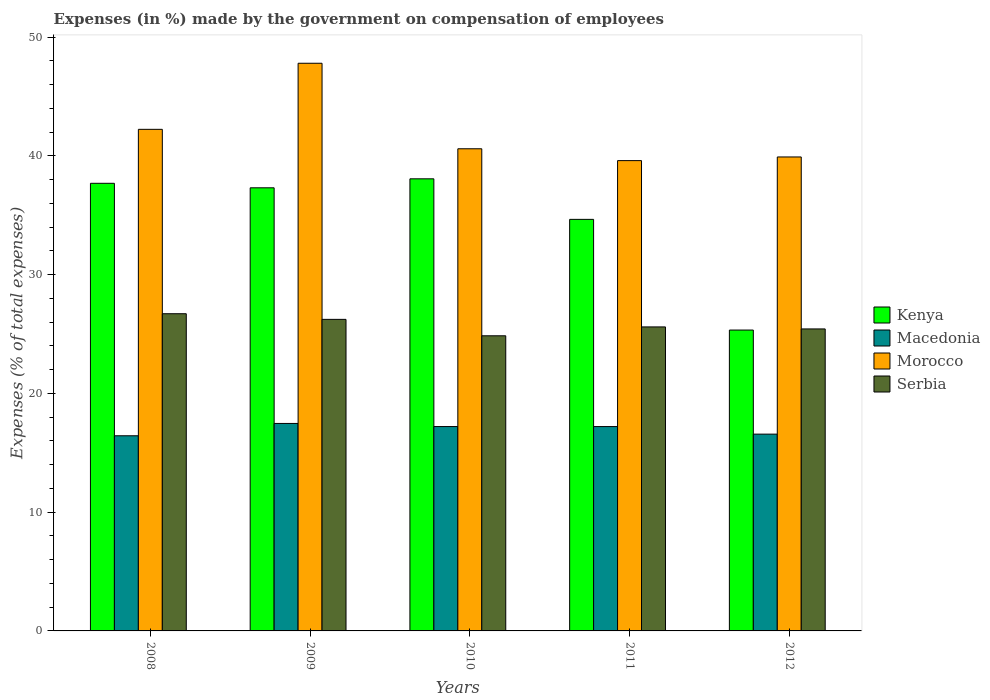How many different coloured bars are there?
Your answer should be compact. 4. Are the number of bars on each tick of the X-axis equal?
Your answer should be very brief. Yes. How many bars are there on the 3rd tick from the left?
Ensure brevity in your answer.  4. What is the label of the 2nd group of bars from the left?
Offer a terse response. 2009. In how many cases, is the number of bars for a given year not equal to the number of legend labels?
Keep it short and to the point. 0. What is the percentage of expenses made by the government on compensation of employees in Macedonia in 2009?
Your answer should be compact. 17.47. Across all years, what is the maximum percentage of expenses made by the government on compensation of employees in Serbia?
Your response must be concise. 26.71. Across all years, what is the minimum percentage of expenses made by the government on compensation of employees in Serbia?
Offer a terse response. 24.85. In which year was the percentage of expenses made by the government on compensation of employees in Morocco minimum?
Your response must be concise. 2011. What is the total percentage of expenses made by the government on compensation of employees in Morocco in the graph?
Provide a succinct answer. 210.13. What is the difference between the percentage of expenses made by the government on compensation of employees in Macedonia in 2008 and that in 2012?
Your response must be concise. -0.14. What is the difference between the percentage of expenses made by the government on compensation of employees in Macedonia in 2010 and the percentage of expenses made by the government on compensation of employees in Kenya in 2009?
Your response must be concise. -20.1. What is the average percentage of expenses made by the government on compensation of employees in Kenya per year?
Your answer should be very brief. 34.61. In the year 2009, what is the difference between the percentage of expenses made by the government on compensation of employees in Kenya and percentage of expenses made by the government on compensation of employees in Morocco?
Your answer should be compact. -10.49. What is the ratio of the percentage of expenses made by the government on compensation of employees in Kenya in 2009 to that in 2012?
Ensure brevity in your answer.  1.47. What is the difference between the highest and the second highest percentage of expenses made by the government on compensation of employees in Kenya?
Make the answer very short. 0.38. What is the difference between the highest and the lowest percentage of expenses made by the government on compensation of employees in Macedonia?
Keep it short and to the point. 1.04. Is it the case that in every year, the sum of the percentage of expenses made by the government on compensation of employees in Morocco and percentage of expenses made by the government on compensation of employees in Macedonia is greater than the sum of percentage of expenses made by the government on compensation of employees in Kenya and percentage of expenses made by the government on compensation of employees in Serbia?
Your answer should be compact. No. What does the 1st bar from the left in 2012 represents?
Provide a short and direct response. Kenya. What does the 4th bar from the right in 2012 represents?
Your response must be concise. Kenya. Is it the case that in every year, the sum of the percentage of expenses made by the government on compensation of employees in Kenya and percentage of expenses made by the government on compensation of employees in Serbia is greater than the percentage of expenses made by the government on compensation of employees in Morocco?
Ensure brevity in your answer.  Yes. Are all the bars in the graph horizontal?
Make the answer very short. No. How many years are there in the graph?
Keep it short and to the point. 5. What is the difference between two consecutive major ticks on the Y-axis?
Provide a succinct answer. 10. Are the values on the major ticks of Y-axis written in scientific E-notation?
Give a very brief answer. No. Does the graph contain any zero values?
Offer a very short reply. No. Does the graph contain grids?
Your response must be concise. No. How are the legend labels stacked?
Keep it short and to the point. Vertical. What is the title of the graph?
Your answer should be very brief. Expenses (in %) made by the government on compensation of employees. Does "India" appear as one of the legend labels in the graph?
Offer a very short reply. No. What is the label or title of the X-axis?
Your answer should be very brief. Years. What is the label or title of the Y-axis?
Make the answer very short. Expenses (% of total expenses). What is the Expenses (% of total expenses) of Kenya in 2008?
Offer a terse response. 37.69. What is the Expenses (% of total expenses) in Macedonia in 2008?
Provide a succinct answer. 16.43. What is the Expenses (% of total expenses) in Morocco in 2008?
Offer a very short reply. 42.23. What is the Expenses (% of total expenses) in Serbia in 2008?
Provide a succinct answer. 26.71. What is the Expenses (% of total expenses) of Kenya in 2009?
Make the answer very short. 37.31. What is the Expenses (% of total expenses) of Macedonia in 2009?
Provide a short and direct response. 17.47. What is the Expenses (% of total expenses) in Morocco in 2009?
Provide a short and direct response. 47.8. What is the Expenses (% of total expenses) of Serbia in 2009?
Provide a short and direct response. 26.23. What is the Expenses (% of total expenses) of Kenya in 2010?
Make the answer very short. 38.07. What is the Expenses (% of total expenses) in Macedonia in 2010?
Offer a very short reply. 17.21. What is the Expenses (% of total expenses) of Morocco in 2010?
Give a very brief answer. 40.6. What is the Expenses (% of total expenses) in Serbia in 2010?
Your answer should be very brief. 24.85. What is the Expenses (% of total expenses) of Kenya in 2011?
Keep it short and to the point. 34.65. What is the Expenses (% of total expenses) in Macedonia in 2011?
Your response must be concise. 17.21. What is the Expenses (% of total expenses) in Morocco in 2011?
Provide a short and direct response. 39.6. What is the Expenses (% of total expenses) of Serbia in 2011?
Give a very brief answer. 25.6. What is the Expenses (% of total expenses) in Kenya in 2012?
Provide a succinct answer. 25.33. What is the Expenses (% of total expenses) of Macedonia in 2012?
Ensure brevity in your answer.  16.57. What is the Expenses (% of total expenses) in Morocco in 2012?
Provide a short and direct response. 39.91. What is the Expenses (% of total expenses) of Serbia in 2012?
Keep it short and to the point. 25.43. Across all years, what is the maximum Expenses (% of total expenses) of Kenya?
Keep it short and to the point. 38.07. Across all years, what is the maximum Expenses (% of total expenses) in Macedonia?
Offer a very short reply. 17.47. Across all years, what is the maximum Expenses (% of total expenses) of Morocco?
Your response must be concise. 47.8. Across all years, what is the maximum Expenses (% of total expenses) of Serbia?
Offer a terse response. 26.71. Across all years, what is the minimum Expenses (% of total expenses) in Kenya?
Your response must be concise. 25.33. Across all years, what is the minimum Expenses (% of total expenses) of Macedonia?
Ensure brevity in your answer.  16.43. Across all years, what is the minimum Expenses (% of total expenses) of Morocco?
Your response must be concise. 39.6. Across all years, what is the minimum Expenses (% of total expenses) in Serbia?
Provide a succinct answer. 24.85. What is the total Expenses (% of total expenses) in Kenya in the graph?
Ensure brevity in your answer.  173.05. What is the total Expenses (% of total expenses) in Macedonia in the graph?
Your response must be concise. 84.88. What is the total Expenses (% of total expenses) of Morocco in the graph?
Give a very brief answer. 210.13. What is the total Expenses (% of total expenses) of Serbia in the graph?
Your response must be concise. 128.81. What is the difference between the Expenses (% of total expenses) in Kenya in 2008 and that in 2009?
Keep it short and to the point. 0.38. What is the difference between the Expenses (% of total expenses) of Macedonia in 2008 and that in 2009?
Your answer should be very brief. -1.04. What is the difference between the Expenses (% of total expenses) of Morocco in 2008 and that in 2009?
Keep it short and to the point. -5.56. What is the difference between the Expenses (% of total expenses) in Serbia in 2008 and that in 2009?
Offer a terse response. 0.48. What is the difference between the Expenses (% of total expenses) in Kenya in 2008 and that in 2010?
Provide a succinct answer. -0.38. What is the difference between the Expenses (% of total expenses) of Macedonia in 2008 and that in 2010?
Keep it short and to the point. -0.78. What is the difference between the Expenses (% of total expenses) of Morocco in 2008 and that in 2010?
Offer a terse response. 1.64. What is the difference between the Expenses (% of total expenses) in Serbia in 2008 and that in 2010?
Ensure brevity in your answer.  1.86. What is the difference between the Expenses (% of total expenses) of Kenya in 2008 and that in 2011?
Provide a succinct answer. 3.04. What is the difference between the Expenses (% of total expenses) in Macedonia in 2008 and that in 2011?
Make the answer very short. -0.77. What is the difference between the Expenses (% of total expenses) in Morocco in 2008 and that in 2011?
Your answer should be very brief. 2.63. What is the difference between the Expenses (% of total expenses) in Kenya in 2008 and that in 2012?
Provide a succinct answer. 12.36. What is the difference between the Expenses (% of total expenses) in Macedonia in 2008 and that in 2012?
Offer a very short reply. -0.14. What is the difference between the Expenses (% of total expenses) of Morocco in 2008 and that in 2012?
Offer a terse response. 2.33. What is the difference between the Expenses (% of total expenses) in Serbia in 2008 and that in 2012?
Offer a very short reply. 1.28. What is the difference between the Expenses (% of total expenses) in Kenya in 2009 and that in 2010?
Provide a succinct answer. -0.76. What is the difference between the Expenses (% of total expenses) of Macedonia in 2009 and that in 2010?
Offer a terse response. 0.26. What is the difference between the Expenses (% of total expenses) of Morocco in 2009 and that in 2010?
Ensure brevity in your answer.  7.2. What is the difference between the Expenses (% of total expenses) in Serbia in 2009 and that in 2010?
Your response must be concise. 1.38. What is the difference between the Expenses (% of total expenses) of Kenya in 2009 and that in 2011?
Offer a terse response. 2.66. What is the difference between the Expenses (% of total expenses) in Macedonia in 2009 and that in 2011?
Your answer should be very brief. 0.26. What is the difference between the Expenses (% of total expenses) in Morocco in 2009 and that in 2011?
Ensure brevity in your answer.  8.2. What is the difference between the Expenses (% of total expenses) of Serbia in 2009 and that in 2011?
Your response must be concise. 0.64. What is the difference between the Expenses (% of total expenses) in Kenya in 2009 and that in 2012?
Provide a succinct answer. 11.98. What is the difference between the Expenses (% of total expenses) in Macedonia in 2009 and that in 2012?
Make the answer very short. 0.9. What is the difference between the Expenses (% of total expenses) in Morocco in 2009 and that in 2012?
Offer a very short reply. 7.89. What is the difference between the Expenses (% of total expenses) in Serbia in 2009 and that in 2012?
Your answer should be very brief. 0.81. What is the difference between the Expenses (% of total expenses) of Kenya in 2010 and that in 2011?
Ensure brevity in your answer.  3.41. What is the difference between the Expenses (% of total expenses) of Macedonia in 2010 and that in 2011?
Offer a terse response. 0. What is the difference between the Expenses (% of total expenses) of Morocco in 2010 and that in 2011?
Your response must be concise. 1. What is the difference between the Expenses (% of total expenses) in Serbia in 2010 and that in 2011?
Your answer should be compact. -0.75. What is the difference between the Expenses (% of total expenses) in Kenya in 2010 and that in 2012?
Offer a terse response. 12.73. What is the difference between the Expenses (% of total expenses) in Macedonia in 2010 and that in 2012?
Make the answer very short. 0.64. What is the difference between the Expenses (% of total expenses) of Morocco in 2010 and that in 2012?
Keep it short and to the point. 0.69. What is the difference between the Expenses (% of total expenses) of Serbia in 2010 and that in 2012?
Ensure brevity in your answer.  -0.58. What is the difference between the Expenses (% of total expenses) in Kenya in 2011 and that in 2012?
Provide a short and direct response. 9.32. What is the difference between the Expenses (% of total expenses) in Macedonia in 2011 and that in 2012?
Make the answer very short. 0.64. What is the difference between the Expenses (% of total expenses) of Morocco in 2011 and that in 2012?
Your answer should be very brief. -0.31. What is the difference between the Expenses (% of total expenses) of Serbia in 2011 and that in 2012?
Give a very brief answer. 0.17. What is the difference between the Expenses (% of total expenses) of Kenya in 2008 and the Expenses (% of total expenses) of Macedonia in 2009?
Keep it short and to the point. 20.22. What is the difference between the Expenses (% of total expenses) of Kenya in 2008 and the Expenses (% of total expenses) of Morocco in 2009?
Your answer should be compact. -10.11. What is the difference between the Expenses (% of total expenses) in Kenya in 2008 and the Expenses (% of total expenses) in Serbia in 2009?
Provide a succinct answer. 11.46. What is the difference between the Expenses (% of total expenses) of Macedonia in 2008 and the Expenses (% of total expenses) of Morocco in 2009?
Your response must be concise. -31.37. What is the difference between the Expenses (% of total expenses) of Macedonia in 2008 and the Expenses (% of total expenses) of Serbia in 2009?
Offer a very short reply. -9.8. What is the difference between the Expenses (% of total expenses) of Morocco in 2008 and the Expenses (% of total expenses) of Serbia in 2009?
Make the answer very short. 16. What is the difference between the Expenses (% of total expenses) of Kenya in 2008 and the Expenses (% of total expenses) of Macedonia in 2010?
Provide a succinct answer. 20.48. What is the difference between the Expenses (% of total expenses) in Kenya in 2008 and the Expenses (% of total expenses) in Morocco in 2010?
Provide a short and direct response. -2.91. What is the difference between the Expenses (% of total expenses) of Kenya in 2008 and the Expenses (% of total expenses) of Serbia in 2010?
Your response must be concise. 12.84. What is the difference between the Expenses (% of total expenses) of Macedonia in 2008 and the Expenses (% of total expenses) of Morocco in 2010?
Keep it short and to the point. -24.16. What is the difference between the Expenses (% of total expenses) in Macedonia in 2008 and the Expenses (% of total expenses) in Serbia in 2010?
Provide a succinct answer. -8.42. What is the difference between the Expenses (% of total expenses) in Morocco in 2008 and the Expenses (% of total expenses) in Serbia in 2010?
Your response must be concise. 17.38. What is the difference between the Expenses (% of total expenses) in Kenya in 2008 and the Expenses (% of total expenses) in Macedonia in 2011?
Make the answer very short. 20.48. What is the difference between the Expenses (% of total expenses) in Kenya in 2008 and the Expenses (% of total expenses) in Morocco in 2011?
Your answer should be very brief. -1.91. What is the difference between the Expenses (% of total expenses) in Kenya in 2008 and the Expenses (% of total expenses) in Serbia in 2011?
Provide a succinct answer. 12.09. What is the difference between the Expenses (% of total expenses) of Macedonia in 2008 and the Expenses (% of total expenses) of Morocco in 2011?
Offer a terse response. -23.17. What is the difference between the Expenses (% of total expenses) in Macedonia in 2008 and the Expenses (% of total expenses) in Serbia in 2011?
Provide a succinct answer. -9.17. What is the difference between the Expenses (% of total expenses) of Morocco in 2008 and the Expenses (% of total expenses) of Serbia in 2011?
Your answer should be very brief. 16.64. What is the difference between the Expenses (% of total expenses) of Kenya in 2008 and the Expenses (% of total expenses) of Macedonia in 2012?
Your response must be concise. 21.12. What is the difference between the Expenses (% of total expenses) of Kenya in 2008 and the Expenses (% of total expenses) of Morocco in 2012?
Keep it short and to the point. -2.22. What is the difference between the Expenses (% of total expenses) of Kenya in 2008 and the Expenses (% of total expenses) of Serbia in 2012?
Make the answer very short. 12.26. What is the difference between the Expenses (% of total expenses) of Macedonia in 2008 and the Expenses (% of total expenses) of Morocco in 2012?
Make the answer very short. -23.48. What is the difference between the Expenses (% of total expenses) in Macedonia in 2008 and the Expenses (% of total expenses) in Serbia in 2012?
Your answer should be very brief. -9. What is the difference between the Expenses (% of total expenses) in Morocco in 2008 and the Expenses (% of total expenses) in Serbia in 2012?
Keep it short and to the point. 16.81. What is the difference between the Expenses (% of total expenses) in Kenya in 2009 and the Expenses (% of total expenses) in Macedonia in 2010?
Keep it short and to the point. 20.1. What is the difference between the Expenses (% of total expenses) of Kenya in 2009 and the Expenses (% of total expenses) of Morocco in 2010?
Offer a very short reply. -3.29. What is the difference between the Expenses (% of total expenses) in Kenya in 2009 and the Expenses (% of total expenses) in Serbia in 2010?
Offer a very short reply. 12.46. What is the difference between the Expenses (% of total expenses) in Macedonia in 2009 and the Expenses (% of total expenses) in Morocco in 2010?
Offer a terse response. -23.13. What is the difference between the Expenses (% of total expenses) in Macedonia in 2009 and the Expenses (% of total expenses) in Serbia in 2010?
Offer a very short reply. -7.38. What is the difference between the Expenses (% of total expenses) in Morocco in 2009 and the Expenses (% of total expenses) in Serbia in 2010?
Offer a terse response. 22.95. What is the difference between the Expenses (% of total expenses) of Kenya in 2009 and the Expenses (% of total expenses) of Macedonia in 2011?
Your answer should be very brief. 20.1. What is the difference between the Expenses (% of total expenses) in Kenya in 2009 and the Expenses (% of total expenses) in Morocco in 2011?
Provide a succinct answer. -2.29. What is the difference between the Expenses (% of total expenses) in Kenya in 2009 and the Expenses (% of total expenses) in Serbia in 2011?
Provide a short and direct response. 11.71. What is the difference between the Expenses (% of total expenses) in Macedonia in 2009 and the Expenses (% of total expenses) in Morocco in 2011?
Offer a very short reply. -22.13. What is the difference between the Expenses (% of total expenses) in Macedonia in 2009 and the Expenses (% of total expenses) in Serbia in 2011?
Your answer should be compact. -8.13. What is the difference between the Expenses (% of total expenses) in Morocco in 2009 and the Expenses (% of total expenses) in Serbia in 2011?
Offer a terse response. 22.2. What is the difference between the Expenses (% of total expenses) in Kenya in 2009 and the Expenses (% of total expenses) in Macedonia in 2012?
Your answer should be compact. 20.74. What is the difference between the Expenses (% of total expenses) in Kenya in 2009 and the Expenses (% of total expenses) in Morocco in 2012?
Make the answer very short. -2.6. What is the difference between the Expenses (% of total expenses) of Kenya in 2009 and the Expenses (% of total expenses) of Serbia in 2012?
Your answer should be very brief. 11.88. What is the difference between the Expenses (% of total expenses) of Macedonia in 2009 and the Expenses (% of total expenses) of Morocco in 2012?
Give a very brief answer. -22.44. What is the difference between the Expenses (% of total expenses) of Macedonia in 2009 and the Expenses (% of total expenses) of Serbia in 2012?
Keep it short and to the point. -7.96. What is the difference between the Expenses (% of total expenses) of Morocco in 2009 and the Expenses (% of total expenses) of Serbia in 2012?
Give a very brief answer. 22.37. What is the difference between the Expenses (% of total expenses) in Kenya in 2010 and the Expenses (% of total expenses) in Macedonia in 2011?
Your response must be concise. 20.86. What is the difference between the Expenses (% of total expenses) of Kenya in 2010 and the Expenses (% of total expenses) of Morocco in 2011?
Offer a very short reply. -1.53. What is the difference between the Expenses (% of total expenses) of Kenya in 2010 and the Expenses (% of total expenses) of Serbia in 2011?
Provide a succinct answer. 12.47. What is the difference between the Expenses (% of total expenses) of Macedonia in 2010 and the Expenses (% of total expenses) of Morocco in 2011?
Your response must be concise. -22.39. What is the difference between the Expenses (% of total expenses) of Macedonia in 2010 and the Expenses (% of total expenses) of Serbia in 2011?
Your answer should be very brief. -8.39. What is the difference between the Expenses (% of total expenses) of Morocco in 2010 and the Expenses (% of total expenses) of Serbia in 2011?
Your answer should be very brief. 15. What is the difference between the Expenses (% of total expenses) of Kenya in 2010 and the Expenses (% of total expenses) of Macedonia in 2012?
Give a very brief answer. 21.5. What is the difference between the Expenses (% of total expenses) of Kenya in 2010 and the Expenses (% of total expenses) of Morocco in 2012?
Provide a short and direct response. -1.84. What is the difference between the Expenses (% of total expenses) in Kenya in 2010 and the Expenses (% of total expenses) in Serbia in 2012?
Ensure brevity in your answer.  12.64. What is the difference between the Expenses (% of total expenses) in Macedonia in 2010 and the Expenses (% of total expenses) in Morocco in 2012?
Offer a very short reply. -22.7. What is the difference between the Expenses (% of total expenses) in Macedonia in 2010 and the Expenses (% of total expenses) in Serbia in 2012?
Provide a succinct answer. -8.22. What is the difference between the Expenses (% of total expenses) in Morocco in 2010 and the Expenses (% of total expenses) in Serbia in 2012?
Give a very brief answer. 15.17. What is the difference between the Expenses (% of total expenses) in Kenya in 2011 and the Expenses (% of total expenses) in Macedonia in 2012?
Ensure brevity in your answer.  18.08. What is the difference between the Expenses (% of total expenses) in Kenya in 2011 and the Expenses (% of total expenses) in Morocco in 2012?
Keep it short and to the point. -5.25. What is the difference between the Expenses (% of total expenses) in Kenya in 2011 and the Expenses (% of total expenses) in Serbia in 2012?
Your answer should be compact. 9.23. What is the difference between the Expenses (% of total expenses) in Macedonia in 2011 and the Expenses (% of total expenses) in Morocco in 2012?
Provide a short and direct response. -22.7. What is the difference between the Expenses (% of total expenses) in Macedonia in 2011 and the Expenses (% of total expenses) in Serbia in 2012?
Your answer should be very brief. -8.22. What is the difference between the Expenses (% of total expenses) of Morocco in 2011 and the Expenses (% of total expenses) of Serbia in 2012?
Your answer should be compact. 14.17. What is the average Expenses (% of total expenses) of Kenya per year?
Your answer should be very brief. 34.61. What is the average Expenses (% of total expenses) in Macedonia per year?
Make the answer very short. 16.98. What is the average Expenses (% of total expenses) in Morocco per year?
Your answer should be compact. 42.03. What is the average Expenses (% of total expenses) in Serbia per year?
Offer a very short reply. 25.76. In the year 2008, what is the difference between the Expenses (% of total expenses) in Kenya and Expenses (% of total expenses) in Macedonia?
Your answer should be compact. 21.26. In the year 2008, what is the difference between the Expenses (% of total expenses) in Kenya and Expenses (% of total expenses) in Morocco?
Provide a short and direct response. -4.54. In the year 2008, what is the difference between the Expenses (% of total expenses) in Kenya and Expenses (% of total expenses) in Serbia?
Offer a terse response. 10.98. In the year 2008, what is the difference between the Expenses (% of total expenses) of Macedonia and Expenses (% of total expenses) of Morocco?
Provide a short and direct response. -25.8. In the year 2008, what is the difference between the Expenses (% of total expenses) in Macedonia and Expenses (% of total expenses) in Serbia?
Provide a succinct answer. -10.28. In the year 2008, what is the difference between the Expenses (% of total expenses) in Morocco and Expenses (% of total expenses) in Serbia?
Ensure brevity in your answer.  15.53. In the year 2009, what is the difference between the Expenses (% of total expenses) in Kenya and Expenses (% of total expenses) in Macedonia?
Offer a very short reply. 19.84. In the year 2009, what is the difference between the Expenses (% of total expenses) in Kenya and Expenses (% of total expenses) in Morocco?
Make the answer very short. -10.49. In the year 2009, what is the difference between the Expenses (% of total expenses) of Kenya and Expenses (% of total expenses) of Serbia?
Your answer should be compact. 11.08. In the year 2009, what is the difference between the Expenses (% of total expenses) of Macedonia and Expenses (% of total expenses) of Morocco?
Your answer should be very brief. -30.33. In the year 2009, what is the difference between the Expenses (% of total expenses) of Macedonia and Expenses (% of total expenses) of Serbia?
Keep it short and to the point. -8.76. In the year 2009, what is the difference between the Expenses (% of total expenses) of Morocco and Expenses (% of total expenses) of Serbia?
Provide a succinct answer. 21.56. In the year 2010, what is the difference between the Expenses (% of total expenses) in Kenya and Expenses (% of total expenses) in Macedonia?
Give a very brief answer. 20.86. In the year 2010, what is the difference between the Expenses (% of total expenses) in Kenya and Expenses (% of total expenses) in Morocco?
Offer a very short reply. -2.53. In the year 2010, what is the difference between the Expenses (% of total expenses) in Kenya and Expenses (% of total expenses) in Serbia?
Your response must be concise. 13.22. In the year 2010, what is the difference between the Expenses (% of total expenses) of Macedonia and Expenses (% of total expenses) of Morocco?
Provide a succinct answer. -23.39. In the year 2010, what is the difference between the Expenses (% of total expenses) of Macedonia and Expenses (% of total expenses) of Serbia?
Provide a succinct answer. -7.64. In the year 2010, what is the difference between the Expenses (% of total expenses) in Morocco and Expenses (% of total expenses) in Serbia?
Your response must be concise. 15.75. In the year 2011, what is the difference between the Expenses (% of total expenses) of Kenya and Expenses (% of total expenses) of Macedonia?
Provide a short and direct response. 17.45. In the year 2011, what is the difference between the Expenses (% of total expenses) in Kenya and Expenses (% of total expenses) in Morocco?
Your answer should be compact. -4.95. In the year 2011, what is the difference between the Expenses (% of total expenses) in Kenya and Expenses (% of total expenses) in Serbia?
Keep it short and to the point. 9.06. In the year 2011, what is the difference between the Expenses (% of total expenses) in Macedonia and Expenses (% of total expenses) in Morocco?
Offer a very short reply. -22.39. In the year 2011, what is the difference between the Expenses (% of total expenses) in Macedonia and Expenses (% of total expenses) in Serbia?
Provide a succinct answer. -8.39. In the year 2011, what is the difference between the Expenses (% of total expenses) in Morocco and Expenses (% of total expenses) in Serbia?
Ensure brevity in your answer.  14. In the year 2012, what is the difference between the Expenses (% of total expenses) of Kenya and Expenses (% of total expenses) of Macedonia?
Give a very brief answer. 8.76. In the year 2012, what is the difference between the Expenses (% of total expenses) of Kenya and Expenses (% of total expenses) of Morocco?
Offer a terse response. -14.57. In the year 2012, what is the difference between the Expenses (% of total expenses) of Kenya and Expenses (% of total expenses) of Serbia?
Your answer should be very brief. -0.09. In the year 2012, what is the difference between the Expenses (% of total expenses) in Macedonia and Expenses (% of total expenses) in Morocco?
Give a very brief answer. -23.34. In the year 2012, what is the difference between the Expenses (% of total expenses) of Macedonia and Expenses (% of total expenses) of Serbia?
Your answer should be compact. -8.86. In the year 2012, what is the difference between the Expenses (% of total expenses) of Morocco and Expenses (% of total expenses) of Serbia?
Offer a terse response. 14.48. What is the ratio of the Expenses (% of total expenses) in Kenya in 2008 to that in 2009?
Provide a short and direct response. 1.01. What is the ratio of the Expenses (% of total expenses) of Macedonia in 2008 to that in 2009?
Give a very brief answer. 0.94. What is the ratio of the Expenses (% of total expenses) in Morocco in 2008 to that in 2009?
Offer a very short reply. 0.88. What is the ratio of the Expenses (% of total expenses) in Serbia in 2008 to that in 2009?
Provide a short and direct response. 1.02. What is the ratio of the Expenses (% of total expenses) in Kenya in 2008 to that in 2010?
Provide a succinct answer. 0.99. What is the ratio of the Expenses (% of total expenses) of Macedonia in 2008 to that in 2010?
Your answer should be very brief. 0.95. What is the ratio of the Expenses (% of total expenses) of Morocco in 2008 to that in 2010?
Ensure brevity in your answer.  1.04. What is the ratio of the Expenses (% of total expenses) in Serbia in 2008 to that in 2010?
Make the answer very short. 1.07. What is the ratio of the Expenses (% of total expenses) in Kenya in 2008 to that in 2011?
Provide a succinct answer. 1.09. What is the ratio of the Expenses (% of total expenses) in Macedonia in 2008 to that in 2011?
Your response must be concise. 0.95. What is the ratio of the Expenses (% of total expenses) of Morocco in 2008 to that in 2011?
Keep it short and to the point. 1.07. What is the ratio of the Expenses (% of total expenses) of Serbia in 2008 to that in 2011?
Your answer should be very brief. 1.04. What is the ratio of the Expenses (% of total expenses) of Kenya in 2008 to that in 2012?
Your response must be concise. 1.49. What is the ratio of the Expenses (% of total expenses) of Macedonia in 2008 to that in 2012?
Keep it short and to the point. 0.99. What is the ratio of the Expenses (% of total expenses) of Morocco in 2008 to that in 2012?
Offer a very short reply. 1.06. What is the ratio of the Expenses (% of total expenses) of Serbia in 2008 to that in 2012?
Your answer should be compact. 1.05. What is the ratio of the Expenses (% of total expenses) of Kenya in 2009 to that in 2010?
Provide a short and direct response. 0.98. What is the ratio of the Expenses (% of total expenses) of Macedonia in 2009 to that in 2010?
Offer a very short reply. 1.02. What is the ratio of the Expenses (% of total expenses) in Morocco in 2009 to that in 2010?
Your answer should be very brief. 1.18. What is the ratio of the Expenses (% of total expenses) of Serbia in 2009 to that in 2010?
Give a very brief answer. 1.06. What is the ratio of the Expenses (% of total expenses) of Kenya in 2009 to that in 2011?
Offer a very short reply. 1.08. What is the ratio of the Expenses (% of total expenses) in Macedonia in 2009 to that in 2011?
Offer a very short reply. 1.02. What is the ratio of the Expenses (% of total expenses) in Morocco in 2009 to that in 2011?
Your response must be concise. 1.21. What is the ratio of the Expenses (% of total expenses) of Serbia in 2009 to that in 2011?
Keep it short and to the point. 1.02. What is the ratio of the Expenses (% of total expenses) in Kenya in 2009 to that in 2012?
Your response must be concise. 1.47. What is the ratio of the Expenses (% of total expenses) in Macedonia in 2009 to that in 2012?
Your answer should be very brief. 1.05. What is the ratio of the Expenses (% of total expenses) in Morocco in 2009 to that in 2012?
Offer a very short reply. 1.2. What is the ratio of the Expenses (% of total expenses) in Serbia in 2009 to that in 2012?
Your answer should be very brief. 1.03. What is the ratio of the Expenses (% of total expenses) of Kenya in 2010 to that in 2011?
Provide a short and direct response. 1.1. What is the ratio of the Expenses (% of total expenses) in Morocco in 2010 to that in 2011?
Give a very brief answer. 1.03. What is the ratio of the Expenses (% of total expenses) in Serbia in 2010 to that in 2011?
Give a very brief answer. 0.97. What is the ratio of the Expenses (% of total expenses) in Kenya in 2010 to that in 2012?
Provide a succinct answer. 1.5. What is the ratio of the Expenses (% of total expenses) of Macedonia in 2010 to that in 2012?
Your answer should be very brief. 1.04. What is the ratio of the Expenses (% of total expenses) in Morocco in 2010 to that in 2012?
Give a very brief answer. 1.02. What is the ratio of the Expenses (% of total expenses) in Serbia in 2010 to that in 2012?
Provide a short and direct response. 0.98. What is the ratio of the Expenses (% of total expenses) in Kenya in 2011 to that in 2012?
Your response must be concise. 1.37. What is the ratio of the Expenses (% of total expenses) of Macedonia in 2011 to that in 2012?
Ensure brevity in your answer.  1.04. What is the ratio of the Expenses (% of total expenses) of Serbia in 2011 to that in 2012?
Offer a terse response. 1.01. What is the difference between the highest and the second highest Expenses (% of total expenses) in Kenya?
Provide a succinct answer. 0.38. What is the difference between the highest and the second highest Expenses (% of total expenses) of Macedonia?
Make the answer very short. 0.26. What is the difference between the highest and the second highest Expenses (% of total expenses) of Morocco?
Your response must be concise. 5.56. What is the difference between the highest and the second highest Expenses (% of total expenses) of Serbia?
Offer a terse response. 0.48. What is the difference between the highest and the lowest Expenses (% of total expenses) of Kenya?
Your answer should be very brief. 12.73. What is the difference between the highest and the lowest Expenses (% of total expenses) in Macedonia?
Offer a terse response. 1.04. What is the difference between the highest and the lowest Expenses (% of total expenses) in Morocco?
Make the answer very short. 8.2. What is the difference between the highest and the lowest Expenses (% of total expenses) of Serbia?
Offer a terse response. 1.86. 